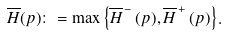<formula> <loc_0><loc_0><loc_500><loc_500>\overline { H } ( p ) \colon = \max \left \{ \overline { H } ^ { \, - } \, ( p ) , \overline { H } ^ { \, + } \, ( p ) \right \} .</formula> 